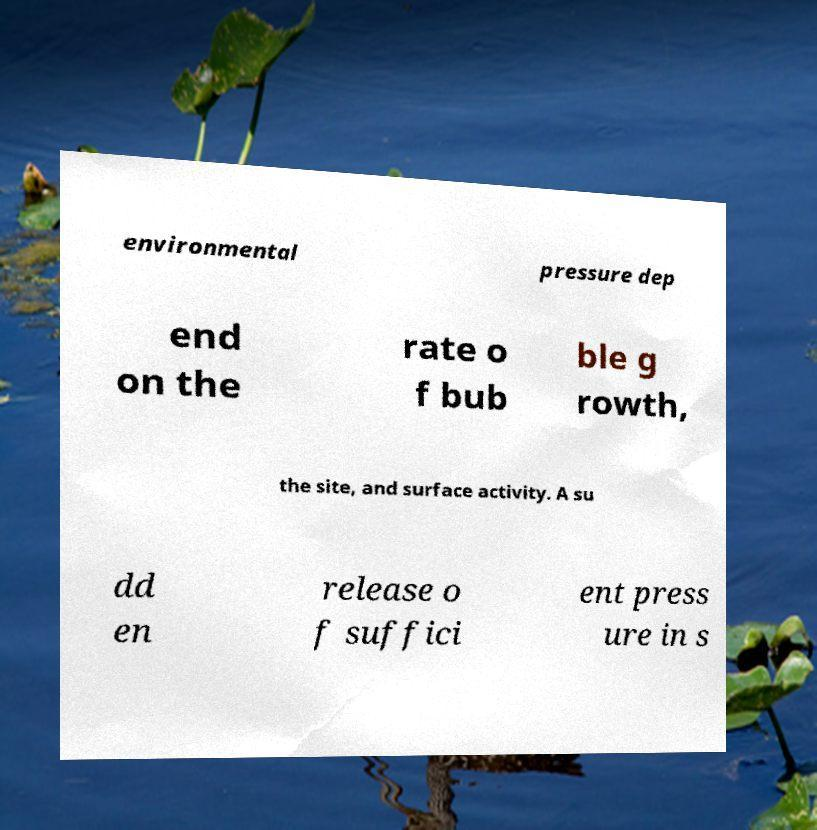Could you extract and type out the text from this image? environmental pressure dep end on the rate o f bub ble g rowth, the site, and surface activity. A su dd en release o f suffici ent press ure in s 